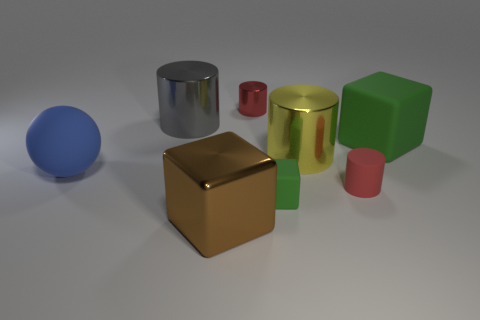How many matte objects are either balls or tiny red spheres?
Your answer should be very brief. 1. What is the size of the red metal cylinder?
Make the answer very short. Small. Do the red metal thing and the yellow cylinder have the same size?
Make the answer very short. No. What material is the small red cylinder in front of the gray object?
Give a very brief answer. Rubber. There is a tiny green object that is the same shape as the big brown object; what is its material?
Keep it short and to the point. Rubber. Are there any tiny green rubber things that are in front of the large block right of the big shiny cube?
Your answer should be compact. Yes. Is the gray object the same shape as the large green rubber object?
Keep it short and to the point. No. What shape is the red thing that is made of the same material as the big blue thing?
Your answer should be compact. Cylinder. Is the size of the cylinder in front of the blue sphere the same as the red thing that is behind the gray cylinder?
Ensure brevity in your answer.  Yes. Is the number of big metallic blocks behind the large blue rubber ball greater than the number of yellow cylinders in front of the tiny red rubber cylinder?
Offer a very short reply. No. 